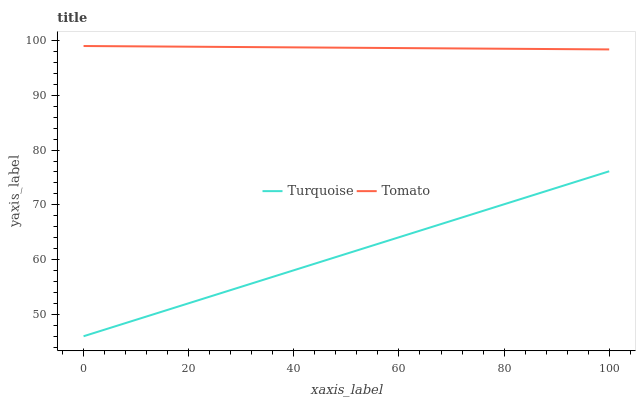Does Turquoise have the maximum area under the curve?
Answer yes or no. No. Is Turquoise the roughest?
Answer yes or no. No. Does Turquoise have the highest value?
Answer yes or no. No. Is Turquoise less than Tomato?
Answer yes or no. Yes. Is Tomato greater than Turquoise?
Answer yes or no. Yes. Does Turquoise intersect Tomato?
Answer yes or no. No. 